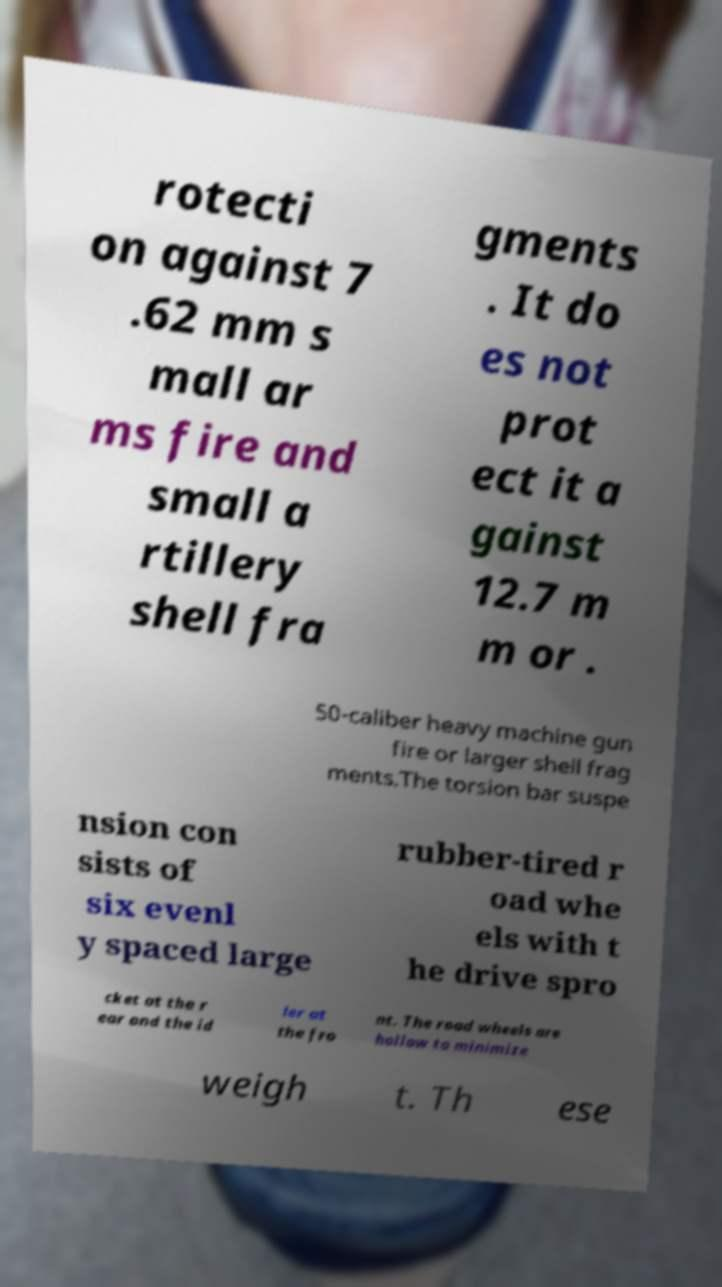There's text embedded in this image that I need extracted. Can you transcribe it verbatim? rotecti on against 7 .62 mm s mall ar ms fire and small a rtillery shell fra gments . It do es not prot ect it a gainst 12.7 m m or . 50-caliber heavy machine gun fire or larger shell frag ments.The torsion bar suspe nsion con sists of six evenl y spaced large rubber-tired r oad whe els with t he drive spro cket at the r ear and the id ler at the fro nt. The road wheels are hollow to minimize weigh t. Th ese 